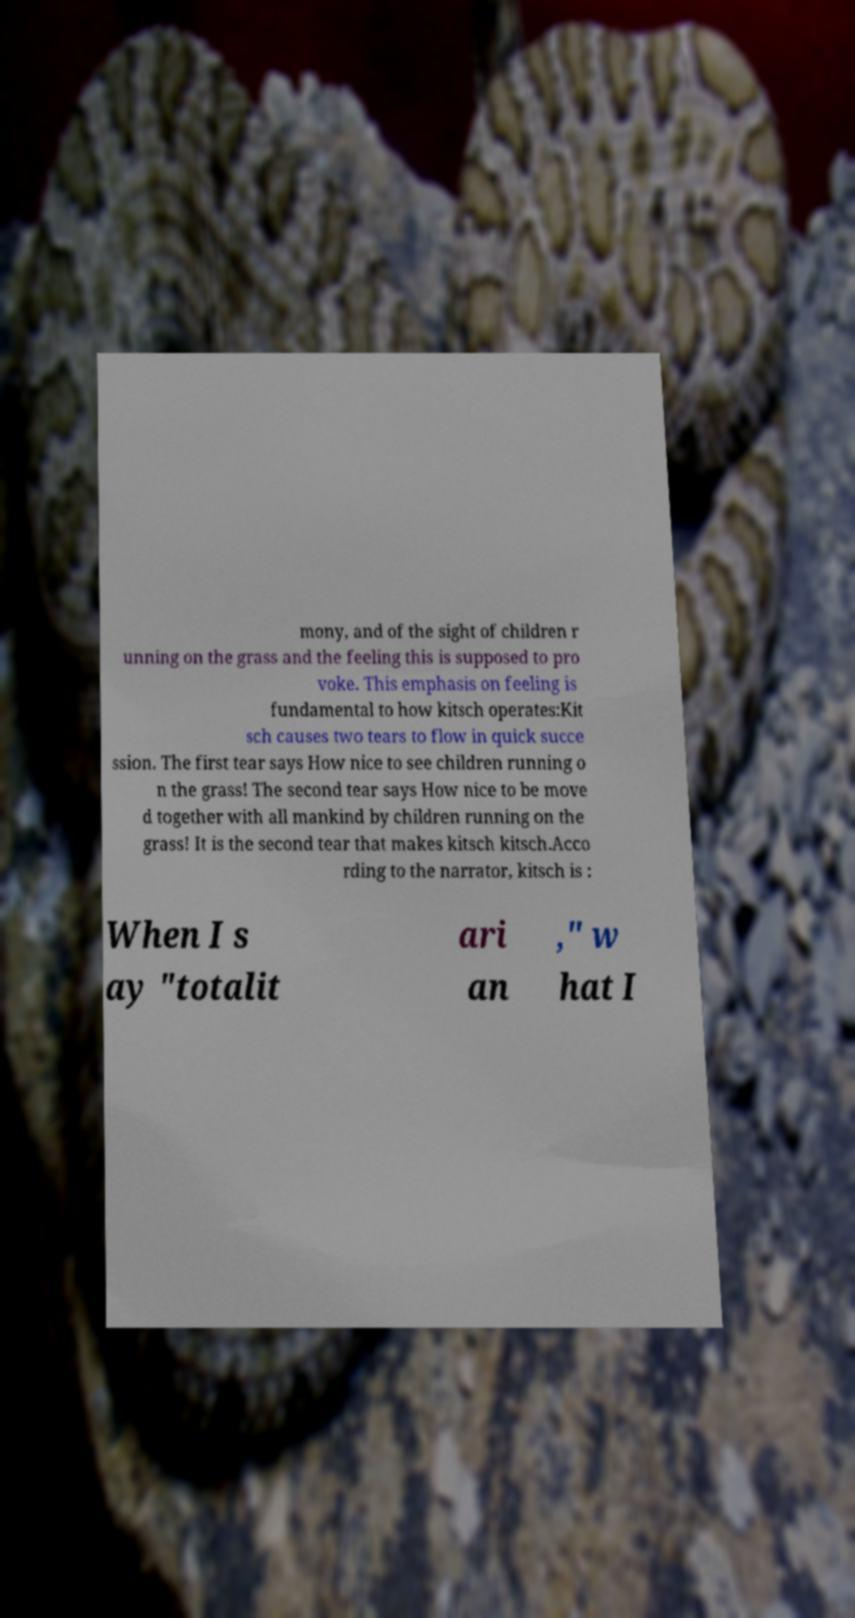I need the written content from this picture converted into text. Can you do that? mony, and of the sight of children r unning on the grass and the feeling this is supposed to pro voke. This emphasis on feeling is fundamental to how kitsch operates:Kit sch causes two tears to flow in quick succe ssion. The first tear says How nice to see children running o n the grass! The second tear says How nice to be move d together with all mankind by children running on the grass! It is the second tear that makes kitsch kitsch.Acco rding to the narrator, kitsch is : When I s ay "totalit ari an ," w hat I 